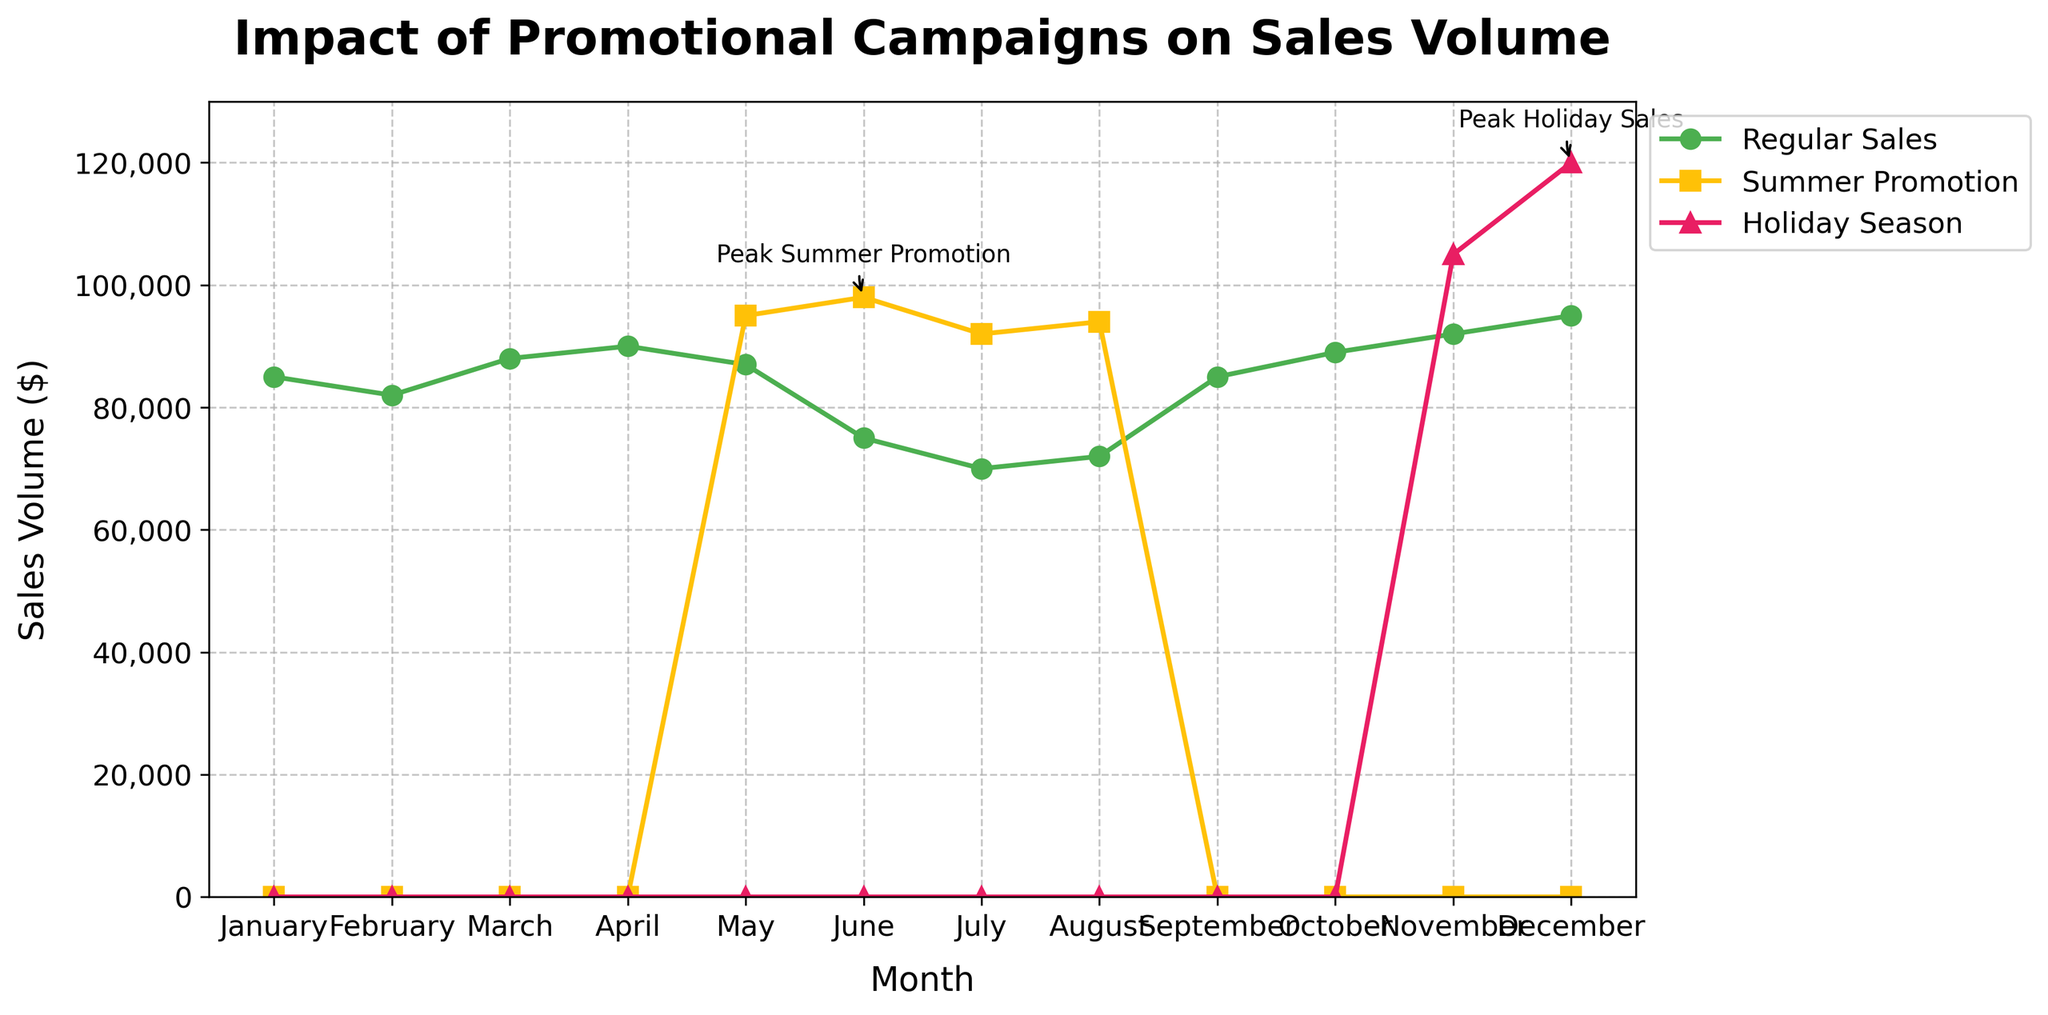Which month had the highest regular sales? Look at the green line representing Regular Sales. The highest point is in December, at $95,000.
Answer: December How do the sales during the Summer Promotion in June compare to regular sales in the same month? Check the yellow line for Summer Promotion Sales and the green line for Regular Sales in June. Summer Promotion Sales were $98,000, while Regular Sales were $75,000. Comparing the two, Summer Promotion Sales surpass regular sales by $23,000.
Answer: Summer Promotion Sales were $23,000 higher What was the percentage increase in sales from May's regular sales to May's Summer Promotion Sales? May's regular sales were $87,000, and Summer Promotion Sales were $95,000. The increase is $95,000 - $87,000 = $8,000. The percentage increase is ($8,000 / $87,000) * 100 = ~9.2%.
Answer: ~9.2% What trend can you observe in the Regular Sales during the summer months (June to August)? Observe the green line from June to August. June shows regular sales of $75,000, July has $70,000, and August has $72,000. The trend indicates a drop in July followed by a slight increase in August, but overall, sales are lower compared to other months.
Answer: Regular Sales drop during summer months Which month experienced the peak in Holiday Season Sales, and how much were the sales? Look at the pink line representing Holiday Season Sales. The peak is in December, with sales reaching $120,000.
Answer: December, $120,000 Compare the impact of Summer Promotion on sales in July to the regular sales in the same month. July's regular sales were $70,000, while Summer Promotion Sales reached $92,000. The Summer Promotion resulted in $22,000 more sales compared to Regular Sales.
Answer: $22,000 more Which month saw the greatest decline in regular sales compared to the previous month? Compare the green line month by month. The biggest drop is from April ($90,000) to May ($87,000), a decline of $20,000.
Answer: June What is the difference in sales between the peak Holiday Season month and the peak Summer Promotion month? The peak Holiday Season month is December with $120,000, and the peak Summer Promotion month is June with $98,000. The difference is $120,000 - $98,000 = $22,000.
Answer: $22,000 What is the overall trend of regular sales throughout the year? Follow the green line from January to December. It starts high, dips in summer, and then gradually increases again towards the end of the year.
Answer: Overall decline in summer, then rise How does November’s regular sales compare to Holiday Season Sales? Look at November’s data on the green and pink lines. Regular sales are $92,000, while Holiday Season Sales are $105,000. Holiday Season Sales are $13,000 higher than regular sales.
Answer: $13,000 higher 